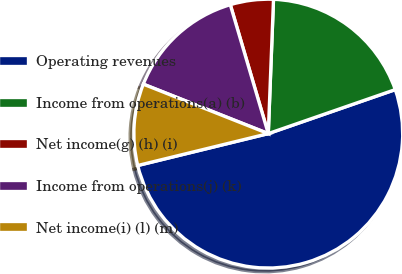<chart> <loc_0><loc_0><loc_500><loc_500><pie_chart><fcel>Operating revenues<fcel>Income from operations(a) (b)<fcel>Net income(g) (h) (i)<fcel>Income from operations(j) (k)<fcel>Net income(i) (l) (m)<nl><fcel>51.49%<fcel>19.07%<fcel>5.18%<fcel>14.44%<fcel>9.81%<nl></chart> 